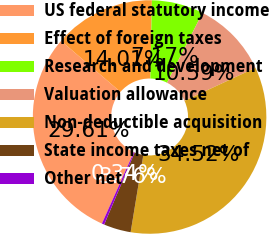Convert chart. <chart><loc_0><loc_0><loc_500><loc_500><pie_chart><fcel>US federal statutory income<fcel>Effect of foreign taxes<fcel>Research and development<fcel>Valuation allowance<fcel>Non-deductible acquisition<fcel>State income taxes net of<fcel>Other net<nl><fcel>29.61%<fcel>14.01%<fcel>7.17%<fcel>10.59%<fcel>34.52%<fcel>3.76%<fcel>0.34%<nl></chart> 